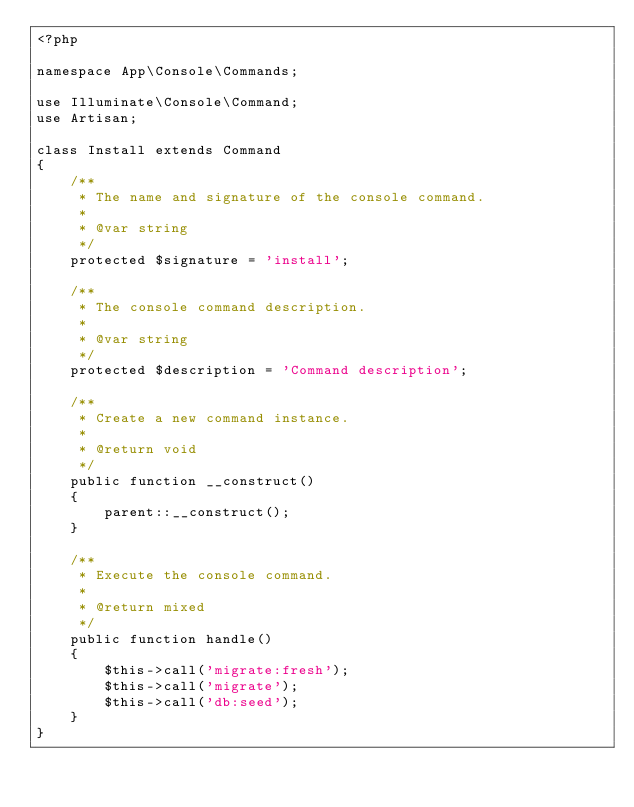<code> <loc_0><loc_0><loc_500><loc_500><_PHP_><?php

namespace App\Console\Commands;

use Illuminate\Console\Command;
use Artisan;

class Install extends Command
{
    /**
     * The name and signature of the console command.
     *
     * @var string
     */
    protected $signature = 'install';

    /**
     * The console command description.
     *
     * @var string
     */
    protected $description = 'Command description';

    /**
     * Create a new command instance.
     *
     * @return void
     */
    public function __construct()
    {
        parent::__construct();
    }

    /**
     * Execute the console command.
     *
     * @return mixed
     */
    public function handle()
    {
        $this->call('migrate:fresh');
        $this->call('migrate');
        $this->call('db:seed');
    }
}
</code> 